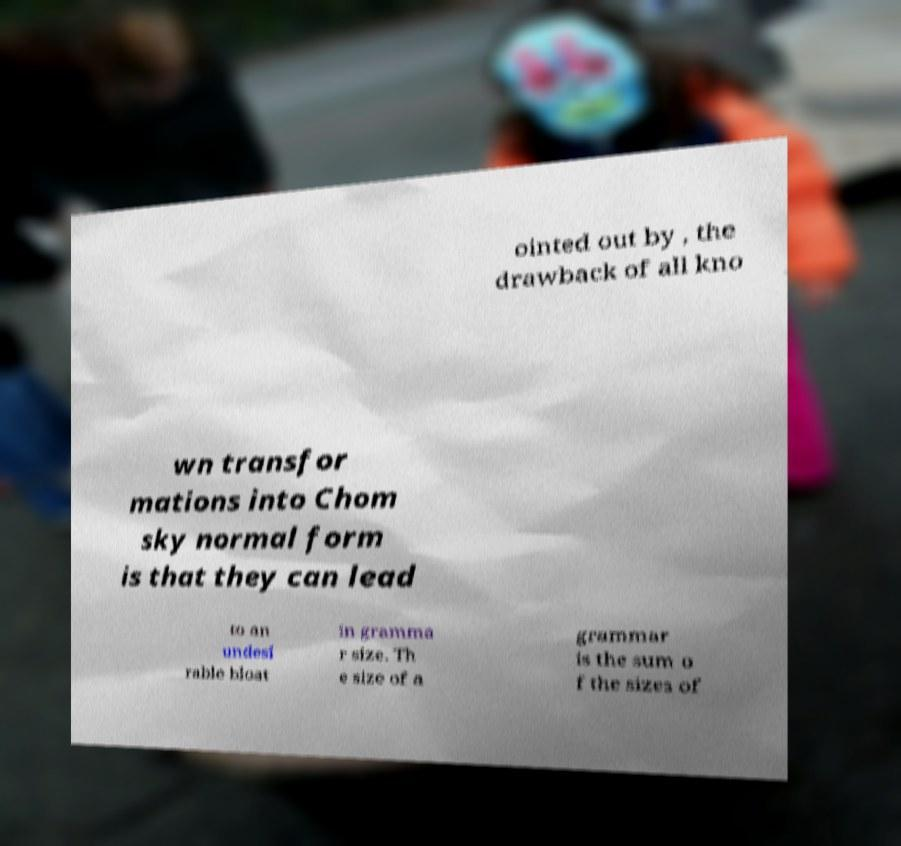Can you read and provide the text displayed in the image?This photo seems to have some interesting text. Can you extract and type it out for me? ointed out by , the drawback of all kno wn transfor mations into Chom sky normal form is that they can lead to an undesi rable bloat in gramma r size. Th e size of a grammar is the sum o f the sizes of 